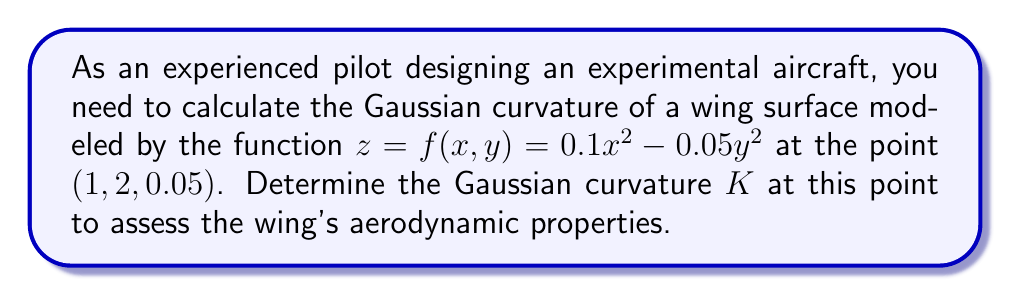Solve this math problem. To calculate the Gaussian curvature K of the surface $z = f(x,y) = 0.1x^2 - 0.05y^2$ at the point (1, 2, 0.05), we'll follow these steps:

1) The Gaussian curvature K is given by:

   $$K = \frac{f_{xx}f_{yy} - f_{xy}^2}{(1 + f_x^2 + f_y^2)^2}$$

   where $f_x$, $f_y$ are first partial derivatives, and $f_{xx}$, $f_{yy}$, $f_{xy}$ are second partial derivatives.

2) Calculate the first partial derivatives:
   
   $f_x = 0.2x$
   $f_y = -0.1y$

3) Calculate the second partial derivatives:
   
   $f_{xx} = 0.2$
   $f_{yy} = -0.1$
   $f_{xy} = 0$

4) Evaluate the derivatives at the point (1, 2):
   
   $f_x(1,2) = 0.2$
   $f_y(1,2) = -0.2$
   $f_{xx}(1,2) = 0.2$
   $f_{yy}(1,2) = -0.1$
   $f_{xy}(1,2) = 0$

5) Substitute these values into the Gaussian curvature formula:

   $$K = \frac{(0.2)(-0.1) - 0^2}{(1 + 0.2^2 + (-0.2)^2)^2}$$

6) Simplify:

   $$K = \frac{-0.02}{(1 + 0.04 + 0.04)^2} = \frac{-0.02}{1.08^2} \approx -0.0171$$
Answer: $K \approx -0.0171$ 